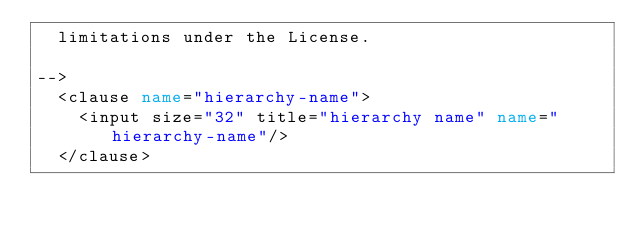Convert code to text. <code><loc_0><loc_0><loc_500><loc_500><_XML_>  limitations under the License.

-->
	<clause name="hierarchy-name">
		<input size="32" title="hierarchy name" name="hierarchy-name"/>
	</clause>	
</code> 